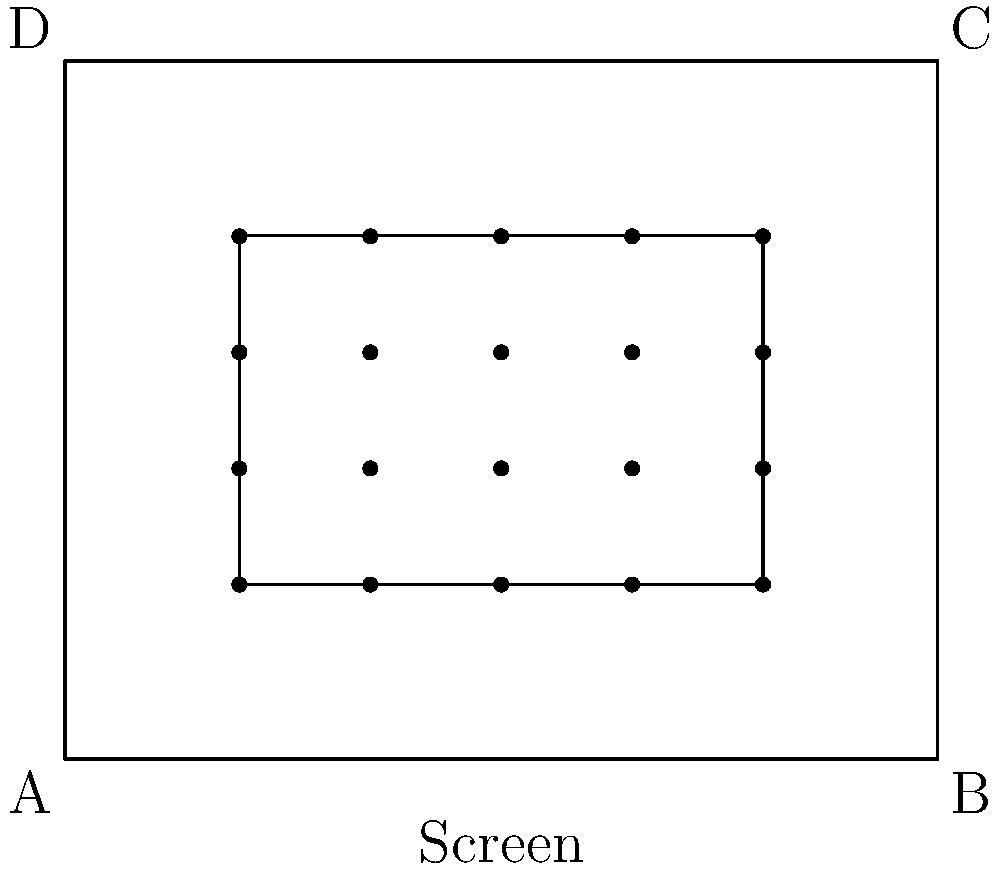In a movie theater, researchers are investigating the impact of seating arrangement on viewer immersion. The theater has a rectangular shape with dimensions 10m x 8m. A study area is marked 2m from each wall, creating an inner rectangle where seats are placed in a grid formation. If there are 5 columns and 4 rows of seats, and each viewer requires a minimum personal space of 1.2m x 1.2m, what is the maximum number of additional seats that could be added to the study area without compromising the minimum personal space requirement? Let's approach this step-by-step:

1) First, we need to calculate the dimensions of the study area:
   Width: 10m - 2m - 2m = 6m
   Height: 8m - 2m - 2m = 4m

2) Now, let's calculate the current space used by each seat:
   Width per column: 6m ÷ 5 = 1.2m
   Height per row: 4m ÷ 4 = 1m

3) The current arrangement satisfies the width requirement (1.2m) but not the height requirement (1.2m).

4) To meet the height requirement, we need to reduce the number of rows:
   Maximum number of rows = 4m ÷ 1.2m = 3.33 (rounded down to 3)

5) Now, let's calculate the new available space:
   Available width: 6m
   Available height: 4m - (3 * 1.2m) = 0.4m

6) We can't add any more rows due to height constraints, so we'll focus on adding columns.

7) Number of additional columns possible:
   0.4m ÷ 1.2m = 0.33 (rounded down to 0)

8) Therefore, we can't add any additional seats while maintaining the minimum personal space requirement.
Answer: 0 seats 